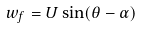<formula> <loc_0><loc_0><loc_500><loc_500>w _ { f } = U \sin ( \theta - \alpha )</formula> 